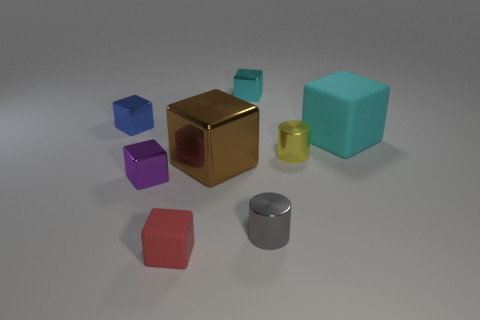Subtract all small red cubes. How many cubes are left? 5 Subtract all brown cubes. How many cubes are left? 5 Subtract all blue blocks. Subtract all yellow spheres. How many blocks are left? 5 Add 1 tiny gray metal objects. How many objects exist? 9 Subtract all blocks. How many objects are left? 2 Subtract 1 red blocks. How many objects are left? 7 Subtract all red shiny balls. Subtract all yellow cylinders. How many objects are left? 7 Add 4 blue cubes. How many blue cubes are left? 5 Add 3 small cyan things. How many small cyan things exist? 4 